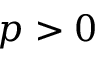Convert formula to latex. <formula><loc_0><loc_0><loc_500><loc_500>p > 0</formula> 